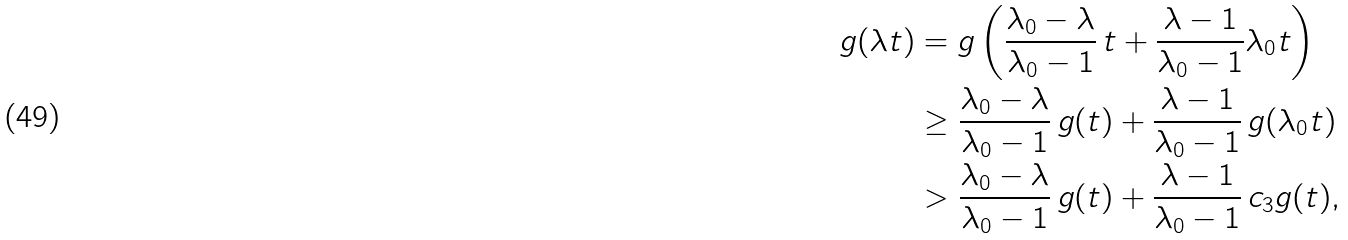Convert formula to latex. <formula><loc_0><loc_0><loc_500><loc_500>g ( \lambda t ) & = g \left ( \frac { \lambda _ { 0 } - \lambda } { \lambda _ { 0 } - 1 } \, t + \frac { \lambda - 1 } { \lambda _ { 0 } - 1 } \lambda _ { 0 } t \right ) \\ & \geq \frac { \lambda _ { 0 } - \lambda } { \lambda _ { 0 } - 1 } \, g ( t ) + \frac { \lambda - 1 } { \lambda _ { 0 } - 1 } \, g ( \lambda _ { 0 } t ) \\ & > \frac { \lambda _ { 0 } - \lambda } { \lambda _ { 0 } - 1 } \, g ( t ) + \frac { \lambda - 1 } { \lambda _ { 0 } - 1 } \, c _ { 3 } g ( t ) ,</formula> 